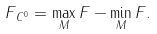Convert formula to latex. <formula><loc_0><loc_0><loc_500><loc_500>\| F \| _ { C ^ { 0 } } = \max _ { M } F - \min _ { M } F .</formula> 